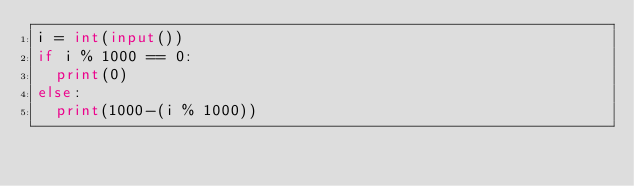<code> <loc_0><loc_0><loc_500><loc_500><_Python_>i = int(input())
if i % 1000 == 0:
	print(0)
else:
	print(1000-(i % 1000))</code> 